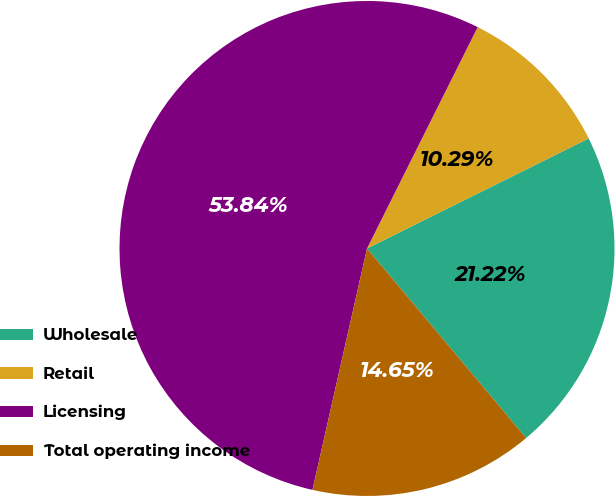Convert chart to OTSL. <chart><loc_0><loc_0><loc_500><loc_500><pie_chart><fcel>Wholesale<fcel>Retail<fcel>Licensing<fcel>Total operating income<nl><fcel>21.22%<fcel>10.29%<fcel>53.84%<fcel>14.65%<nl></chart> 